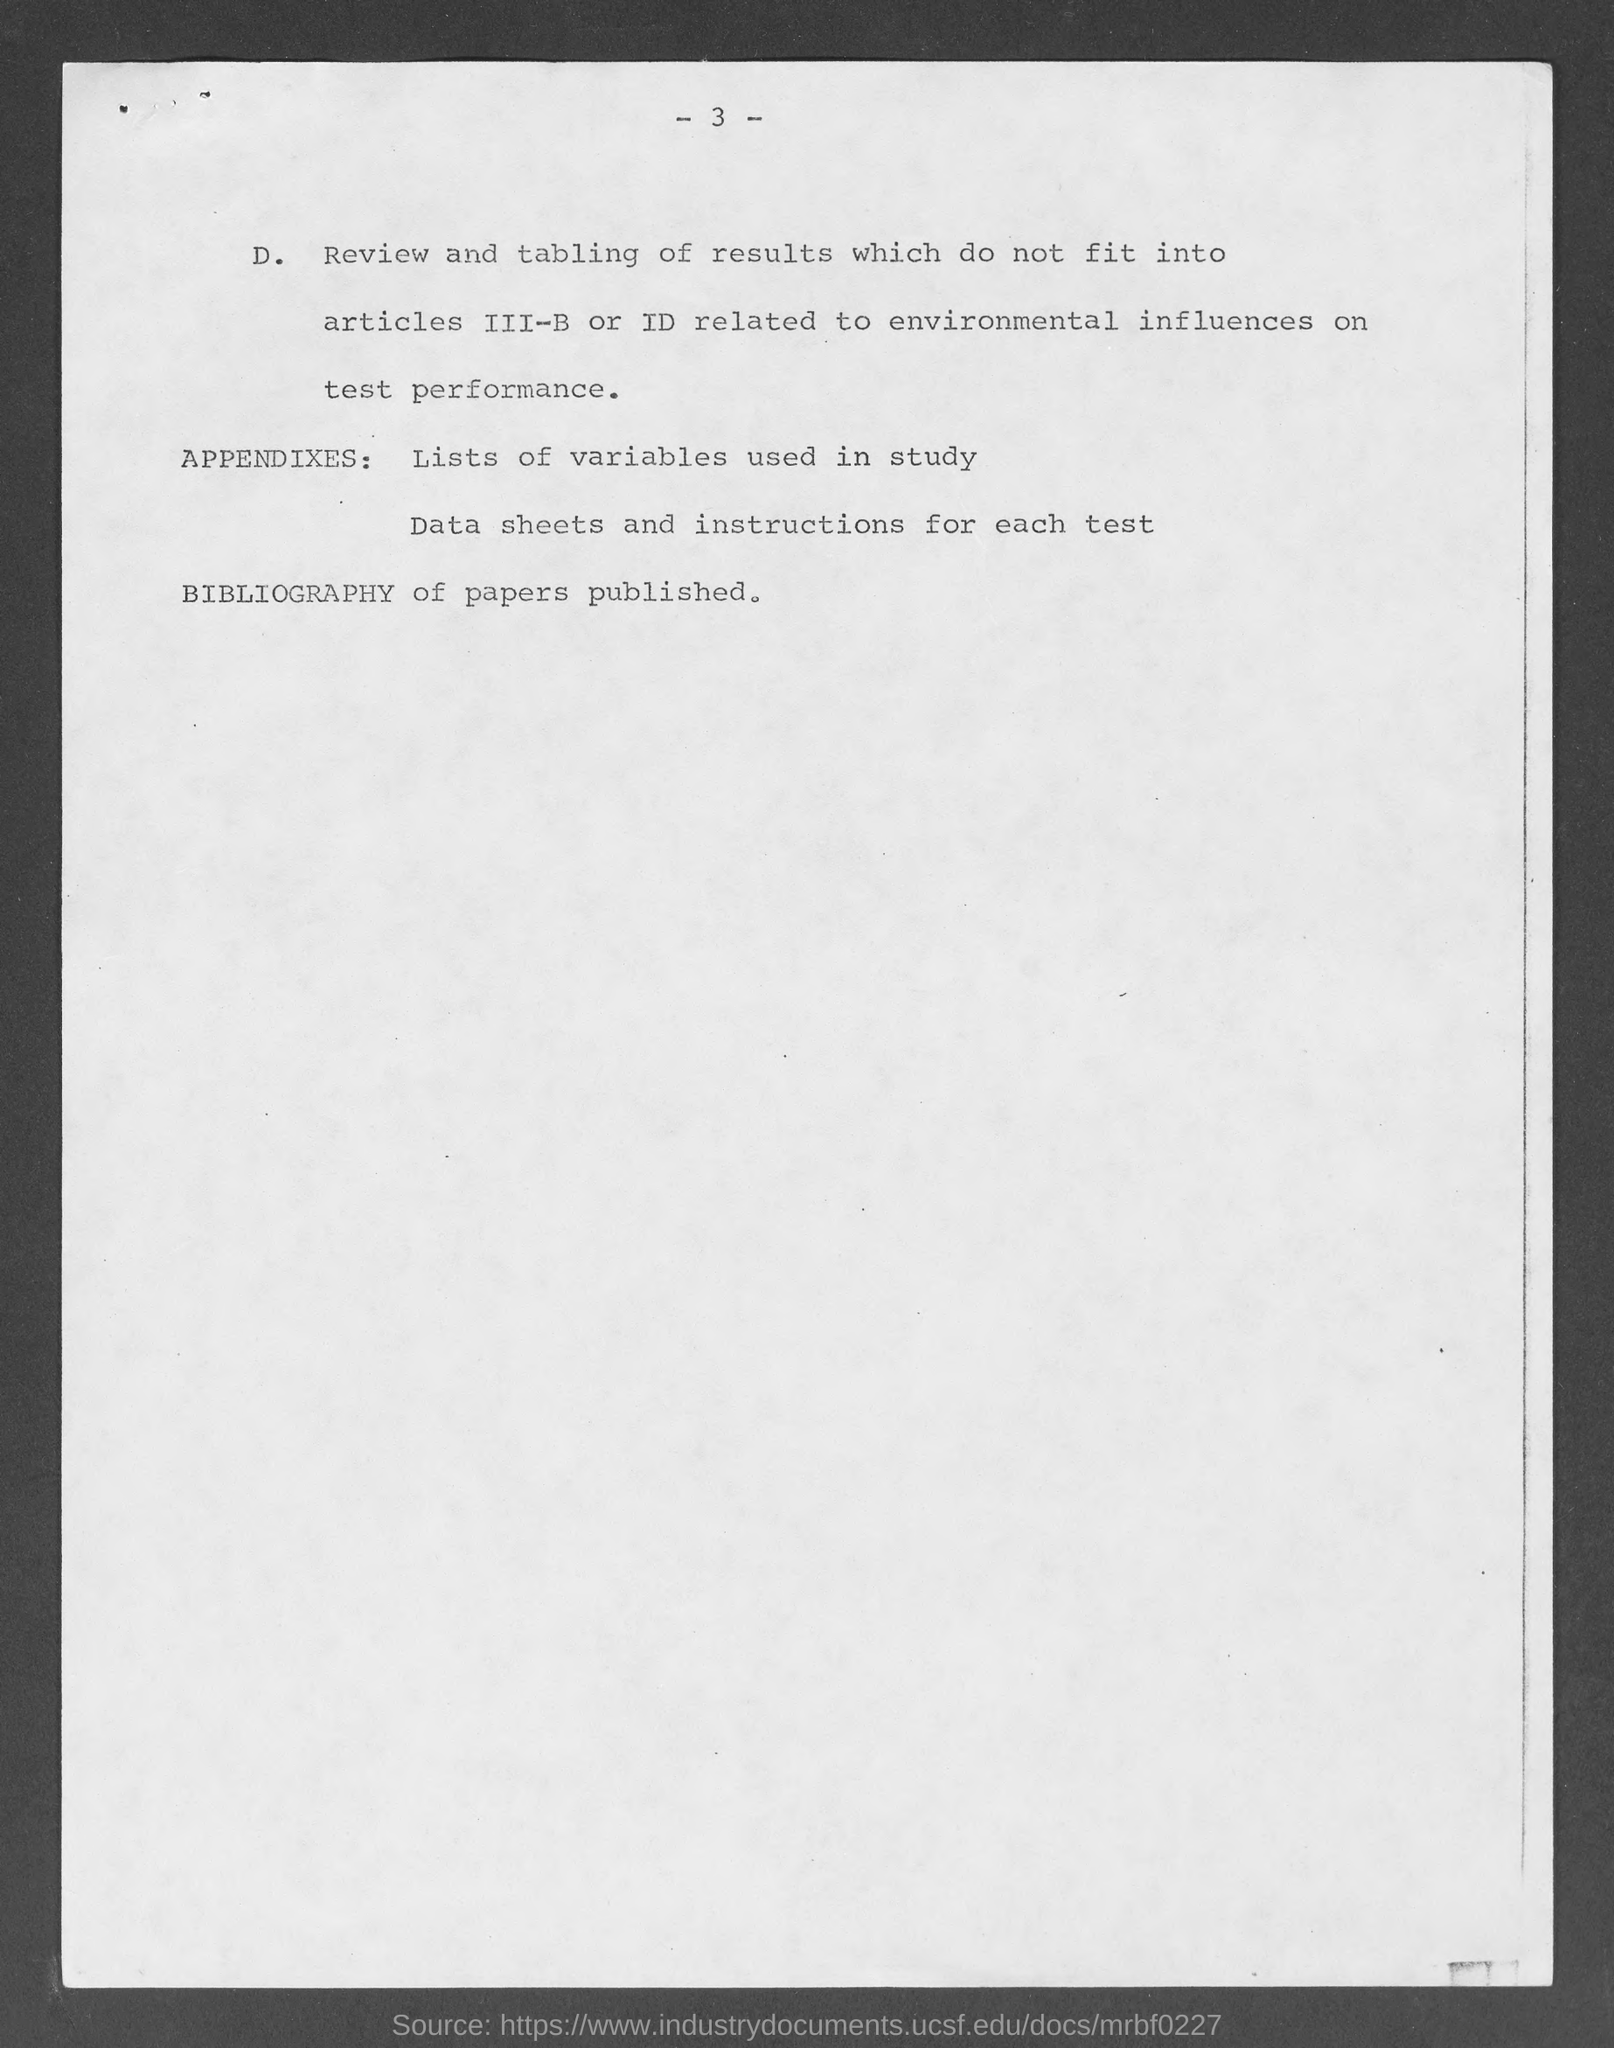Point out several critical features in this image. The page number is 3. 